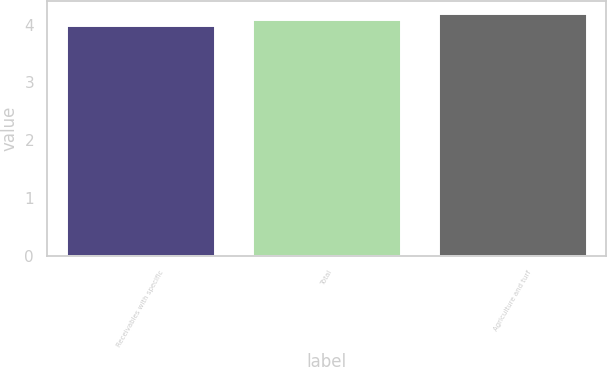Convert chart. <chart><loc_0><loc_0><loc_500><loc_500><bar_chart><fcel>Receivables with specific<fcel>Total<fcel>Agriculture and turf<nl><fcel>4<fcel>4.1<fcel>4.2<nl></chart> 